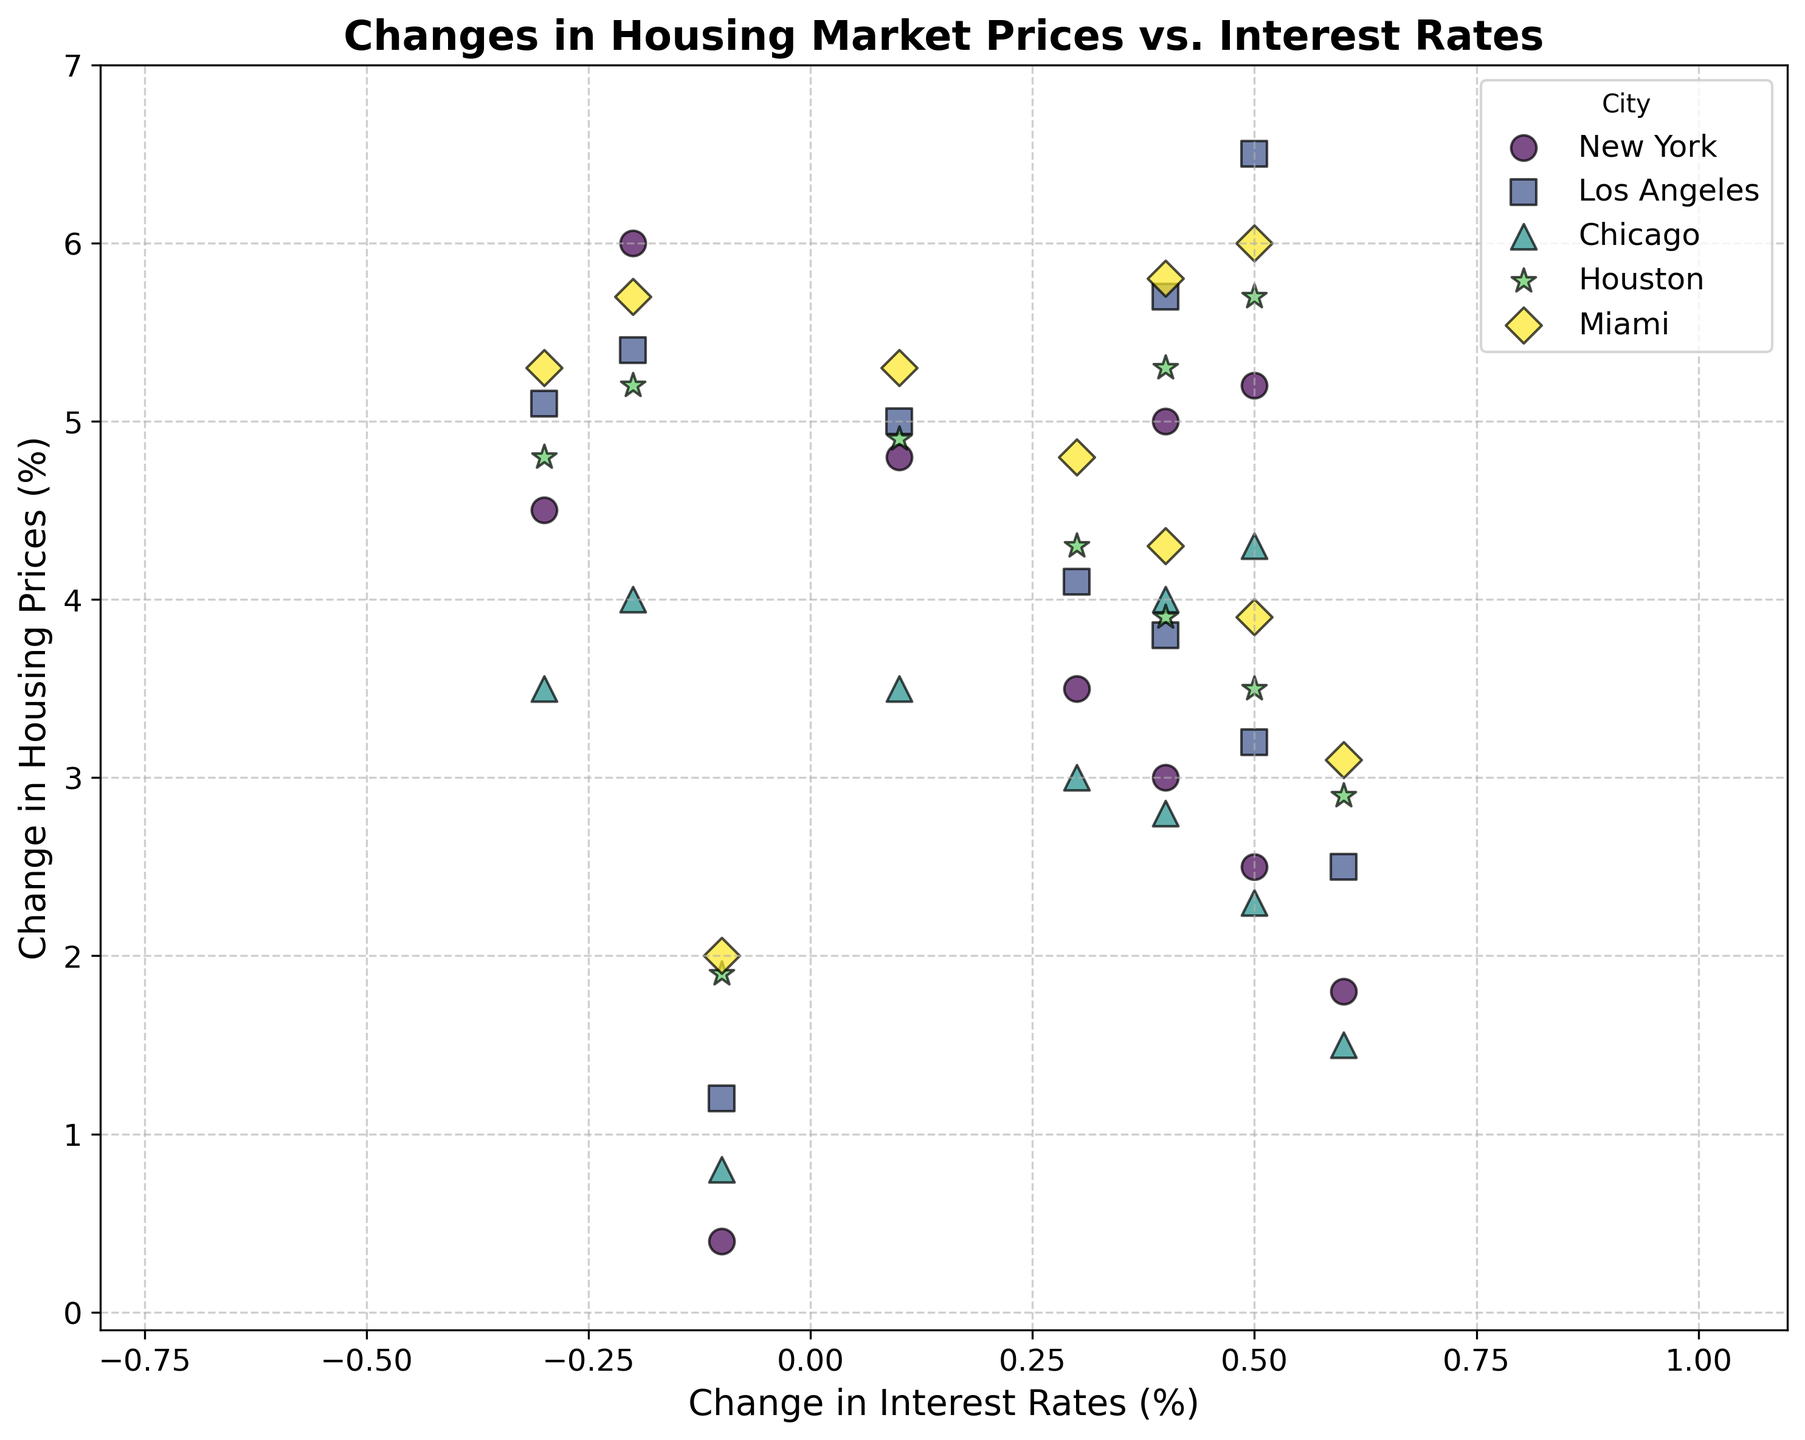What city has the most negative change in interest rates? The figure shows the scatter points for each city with their respective changes in interest rates and housing prices. Identify the point that has the most negative value on the x-axis (interest rates). The city corresponding to the most leftward point is the answer.
Answer: New York Which city experienced the largest range in housing price changes over the decade? By observing the range of scatter points on the y-axis (change in housing prices) for each city, the city with the widest vertical spread is the one that experienced the largest range in housing price changes.
Answer: Los Angeles Which city has scatter points that suggest a positive correlation between changes in housing prices and interest rates? Identify the city whose scatter points generally show a trend where increases in interest rates correspond with increases in housing prices, and vice versa. A positive correlation would appear as an upward trend from left to right.
Answer: New York For which city do the scatter points seem to be the most clustered, indicating the least variability in changes? Look for the city whose points are most closely packed together both horizontally (interest rates) and vertically (housing prices), indicating less variability.
Answer: Chicago What is the average change in housing prices when interest rates decrease? Isolate the scatter points where interest rates have negative values (left side of the y-axis). Then, calculate the average of the corresponding housing price changes for those points.
Answer: Around 3.72% Compare the change in interest rates between Miami and Chicago in 2021. Which city has a more significant change, and what is the difference? Locate the scatter points for Miami and Chicago in 2021, then compare their positions on the x-axis (interest rates). Calculate the absolute difference between the values.
Answer: Miami had the more significant change, and the difference is 0.0% (both -0.3) Which city had the greatest positive change in housing prices in 2022? Check the scatter points for the year 2022 for each city and identify the highest point on the y-axis (housing prices).
Answer: Miami How does the change in housing prices for New York in 2018 compare to Los Angeles in 2019? Find the scatter points for New York in 2018 and Los Angeles in 2019, then compare their positions on the y-axis (housing prices).
Answer: New York in 2018 (2.5%) is higher than Los Angeles in 2019 (2.5%) What is the general trend in changes in housing prices for Houston over the decade? Observe the series of scatter points for Houston from 2013 to 2022. Note whether there is a general increase, decrease, or no clear trend in the changes in housing prices.
Answer: General decrease with fluctuations What is the combined average change in interest rates for all cities in 2020? Aggregate the scatter points for all cities in 2020, sum the changes in interest rates, and divide by the number of cities to find the average.
Answer: -0.1 